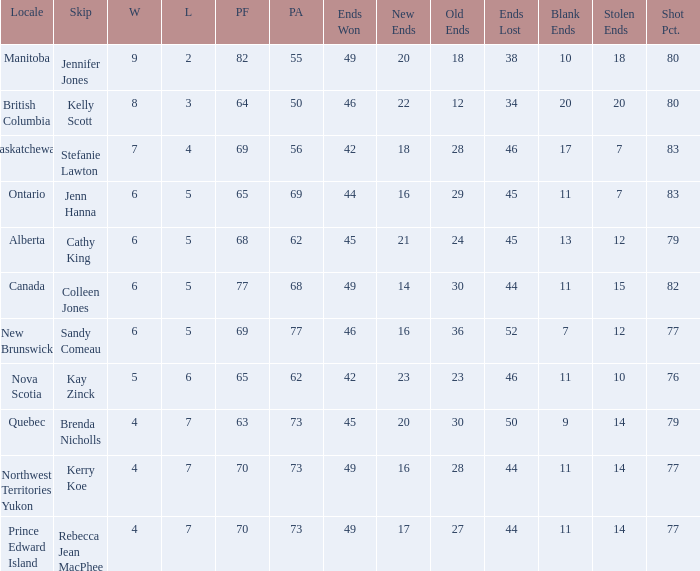What is the PA when the PF is 77? 68.0. I'm looking to parse the entire table for insights. Could you assist me with that? {'header': ['Locale', 'Skip', 'W', 'L', 'PF', 'PA', 'Ends Won', 'New Ends', 'Old Ends', 'Ends Lost', 'Blank Ends', 'Stolen Ends', 'Shot Pct.'], 'rows': [['Manitoba', 'Jennifer Jones', '9', '2', '82', '55', '49', '20', '18', '38', '10', '18', '80'], ['British Columbia', 'Kelly Scott', '8', '3', '64', '50', '46', '22', '12', '34', '20', '20', '80'], ['Saskatchewan', 'Stefanie Lawton', '7', '4', '69', '56', '42', '18', '28', '46', '17', '7', '83'], ['Ontario', 'Jenn Hanna', '6', '5', '65', '69', '44', '16', '29', '45', '11', '7', '83'], ['Alberta', 'Cathy King', '6', '5', '68', '62', '45', '21', '24', '45', '13', '12', '79'], ['Canada', 'Colleen Jones', '6', '5', '77', '68', '49', '14', '30', '44', '11', '15', '82'], ['New Brunswick', 'Sandy Comeau', '6', '5', '69', '77', '46', '16', '36', '52', '7', '12', '77'], ['Nova Scotia', 'Kay Zinck', '5', '6', '65', '62', '42', '23', '23', '46', '11', '10', '76'], ['Quebec', 'Brenda Nicholls', '4', '7', '63', '73', '45', '20', '30', '50', '9', '14', '79'], ['Northwest Territories Yukon', 'Kerry Koe', '4', '7', '70', '73', '49', '16', '28', '44', '11', '14', '77'], ['Prince Edward Island', 'Rebecca Jean MacPhee', '4', '7', '70', '73', '49', '17', '27', '44', '11', '14', '77']]} 